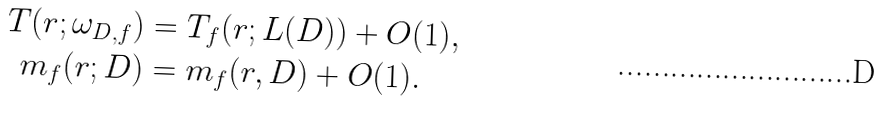Convert formula to latex. <formula><loc_0><loc_0><loc_500><loc_500>T ( r ; \omega _ { D , f } ) & = T _ { f } ( r ; L ( D ) ) + O ( 1 ) , \\ m _ { f } ( r ; D ) & = m _ { f } ( r , D ) + O ( 1 ) .</formula> 